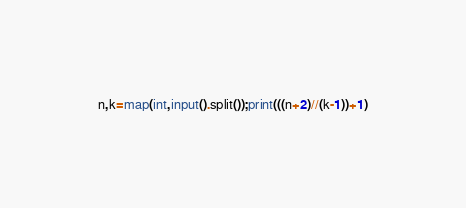<code> <loc_0><loc_0><loc_500><loc_500><_Python_>n,k=map(int,input().split());print(((n+2)//(k-1))+1)</code> 